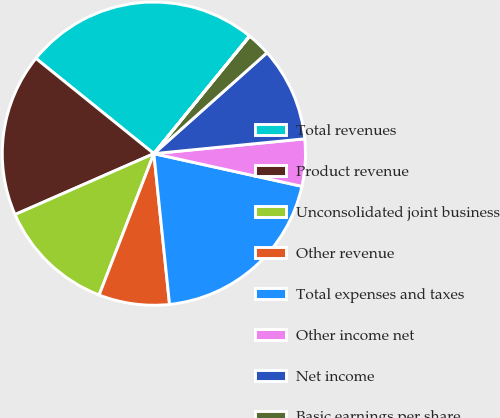<chart> <loc_0><loc_0><loc_500><loc_500><pie_chart><fcel>Total revenues<fcel>Product revenue<fcel>Unconsolidated joint business<fcel>Other revenue<fcel>Total expenses and taxes<fcel>Other income net<fcel>Net income<fcel>Basic earnings per share<fcel>Diluted earnings per share<nl><fcel>25.06%<fcel>17.39%<fcel>12.54%<fcel>7.53%<fcel>19.89%<fcel>5.02%<fcel>10.03%<fcel>2.52%<fcel>0.02%<nl></chart> 